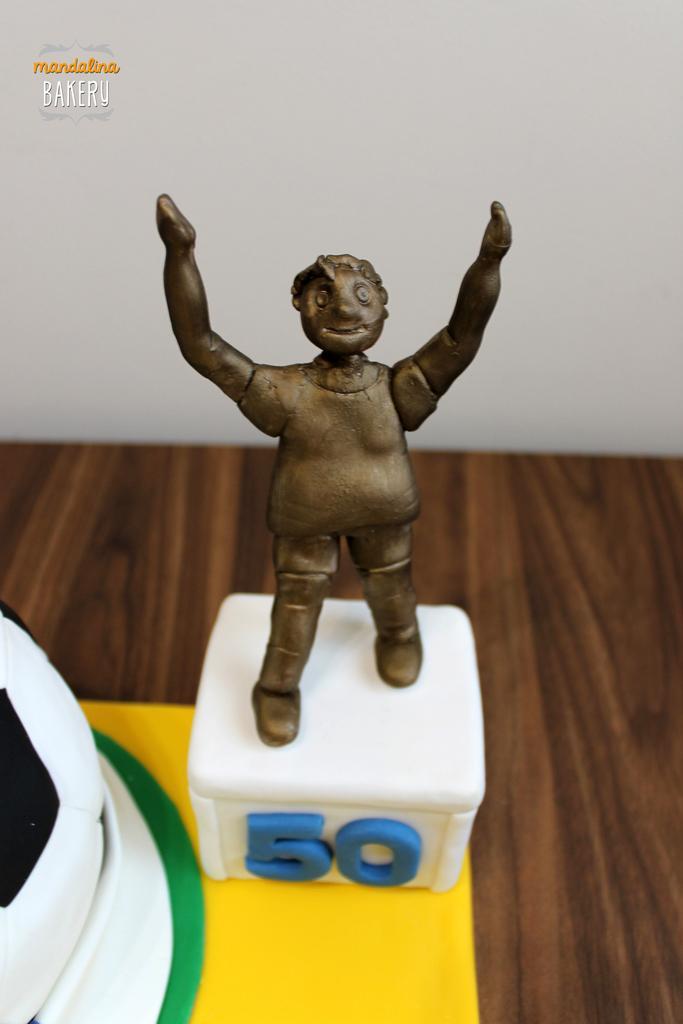Please provide a concise description of this image. There is a statue on a white color box. On the box there is a number. It is on a yellow surface. And there is a wooden table. In the back there's a wall. There is a watermark on the left top corner. On the left down corner there is a white color thing. 